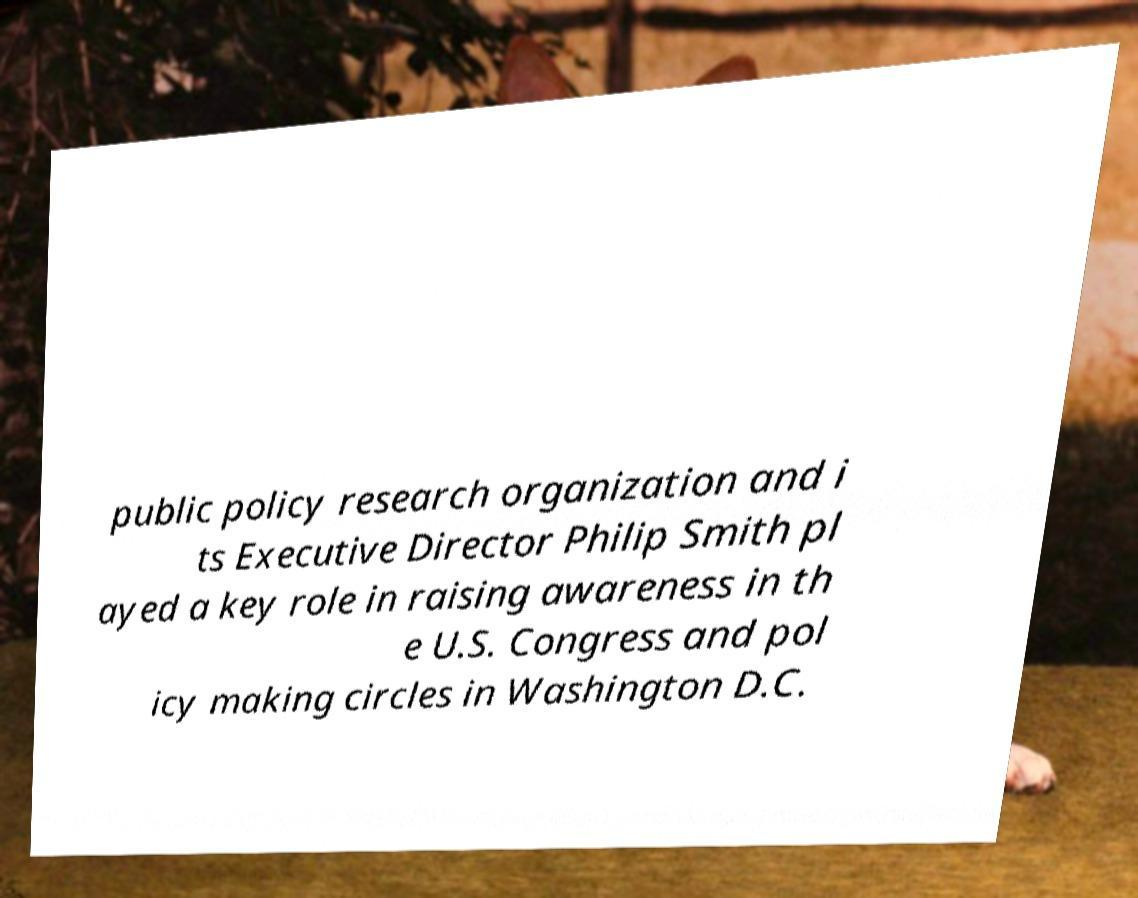Could you extract and type out the text from this image? public policy research organization and i ts Executive Director Philip Smith pl ayed a key role in raising awareness in th e U.S. Congress and pol icy making circles in Washington D.C. 